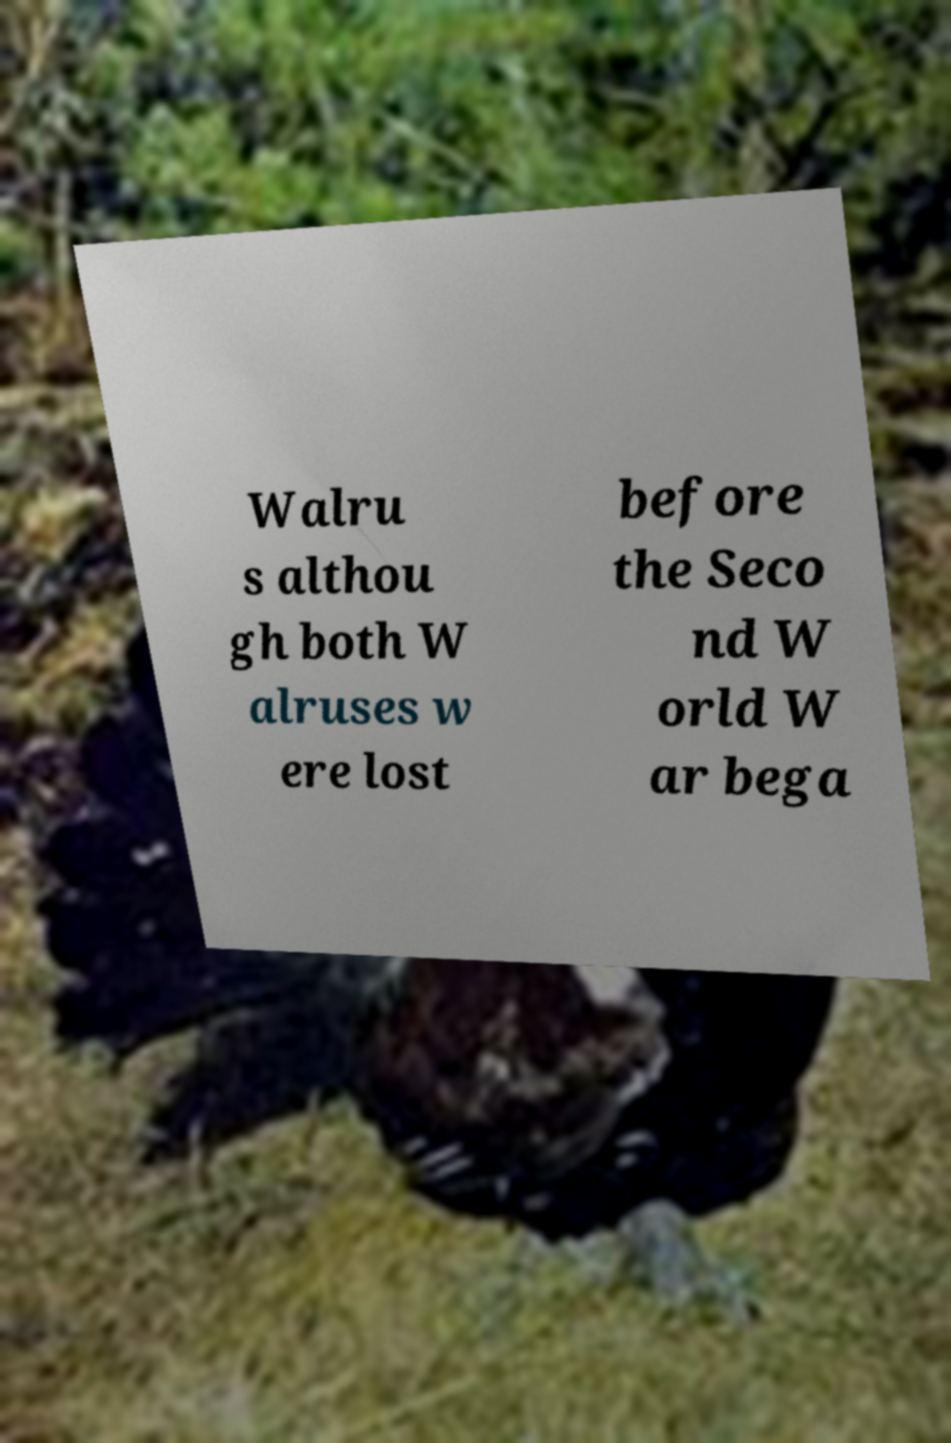I need the written content from this picture converted into text. Can you do that? Walru s althou gh both W alruses w ere lost before the Seco nd W orld W ar bega 